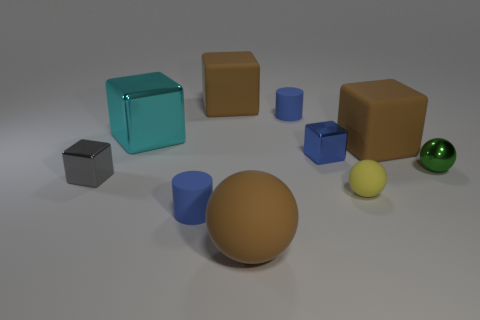Subtract all gray cubes. How many cubes are left? 4 Subtract all cyan cubes. How many cubes are left? 4 Subtract all purple blocks. Subtract all yellow cylinders. How many blocks are left? 5 Subtract all cylinders. How many objects are left? 8 Subtract 0 blue balls. How many objects are left? 10 Subtract all tiny cyan metal balls. Subtract all large matte objects. How many objects are left? 7 Add 6 blue rubber cylinders. How many blue rubber cylinders are left? 8 Add 2 rubber balls. How many rubber balls exist? 4 